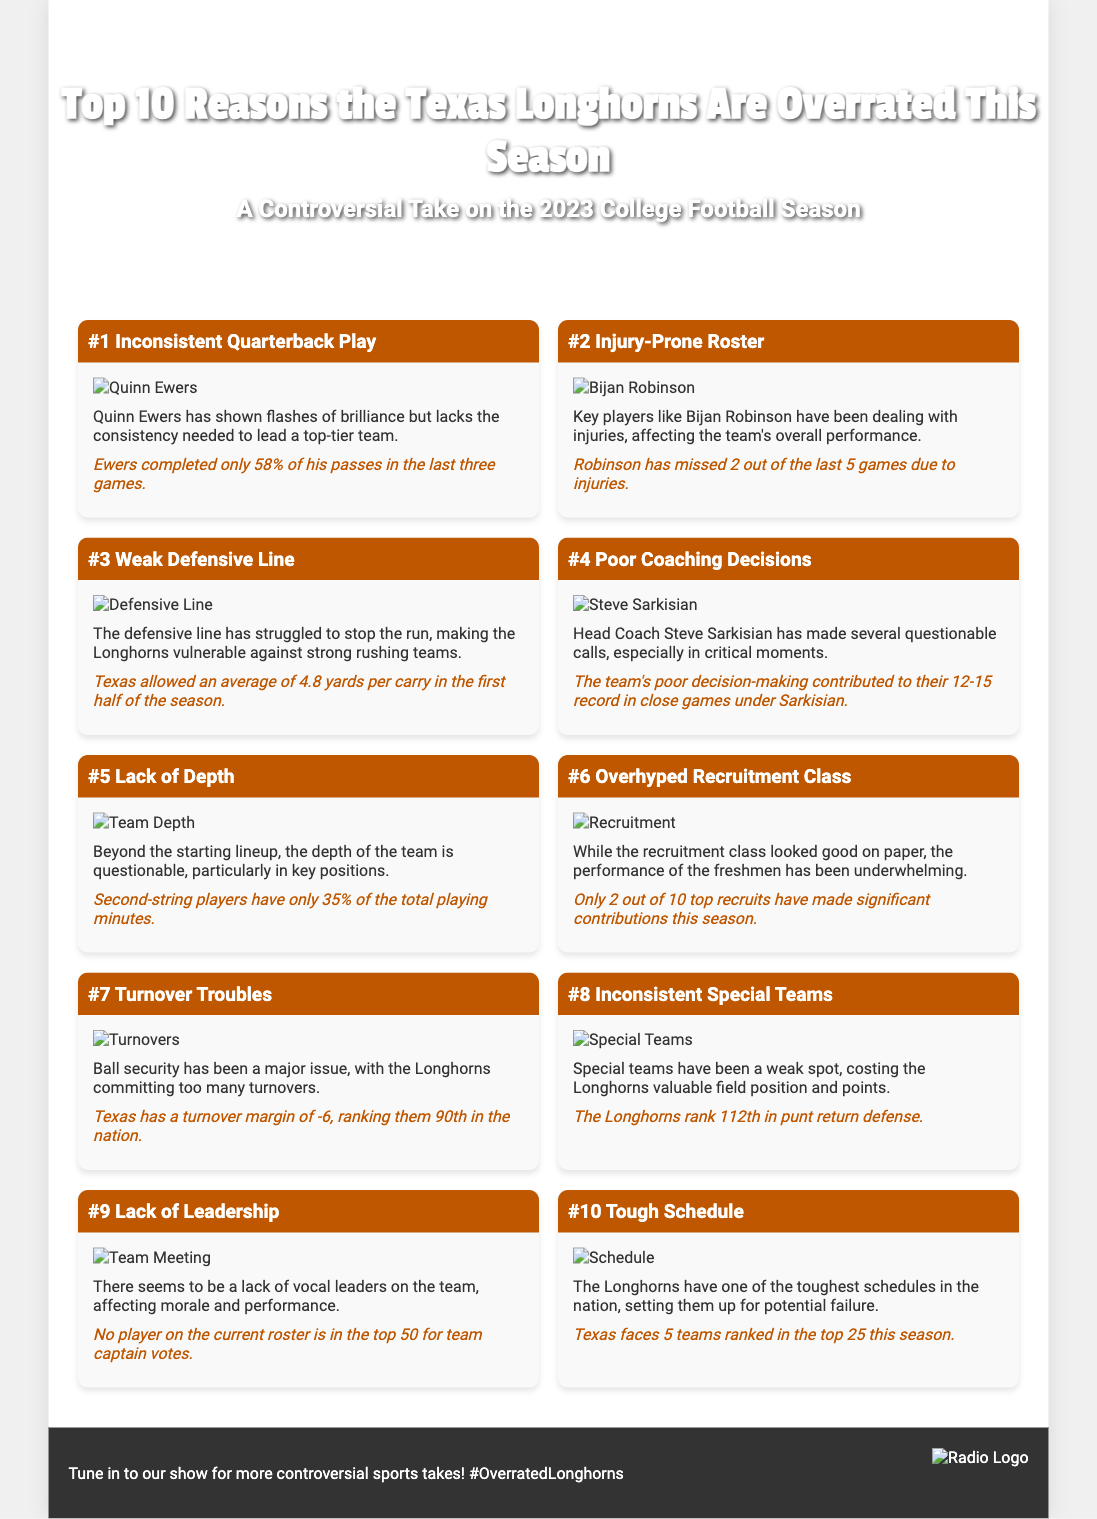What is the title of the document? The title is presented prominently at the top of the flyer as the main heading.
Answer: Top 10 Reasons the Texas Longhorns Are Overrated This Season Who is the head coach mentioned in the document? The document identifies the head coach of the Longhorns in relation to poor coaching decisions.
Answer: Steve Sarkisian What is the average yards allowed per carry by Texas? This statistic is highlighted as a measure of the team's defensive performance in the first half of the season.
Answer: 4.8 yards per carry How many teams ranked in the top 25 do the Longhorns face this season? The document cites the number of ranked teams in relation to Texas's tough schedule.
Answer: 5 teams What percentage of total playing minutes do second-string players have? This figure is provided to illustrate the depth of the team beyond the starters.
Answer: 35% Which player has missed 2 out of the last 5 games? The document includes a specific player who has been affected by injuries, impacting team performance.
Answer: Bijan Robinson What ranking does Texas hold in punt return defense? The document includes a ranking that indicates a specific performance aspect of the special teams.
Answer: 112th How many top recruits have made significant contributions this season? This statistic provides insight into the effectiveness of the recruitment class.
Answer: 2 out of 10 